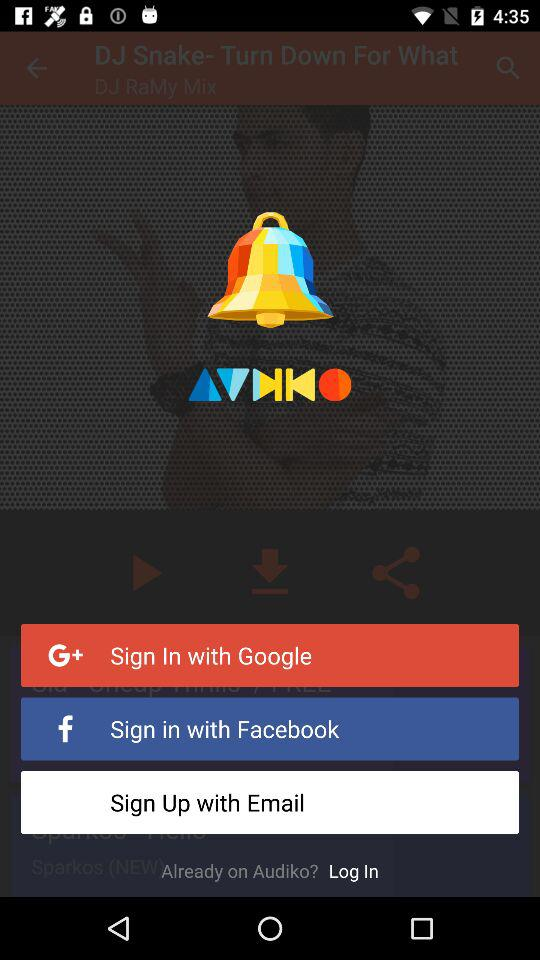How can we sign up? You can sign up with "Google", "Facebook" and "Email". 